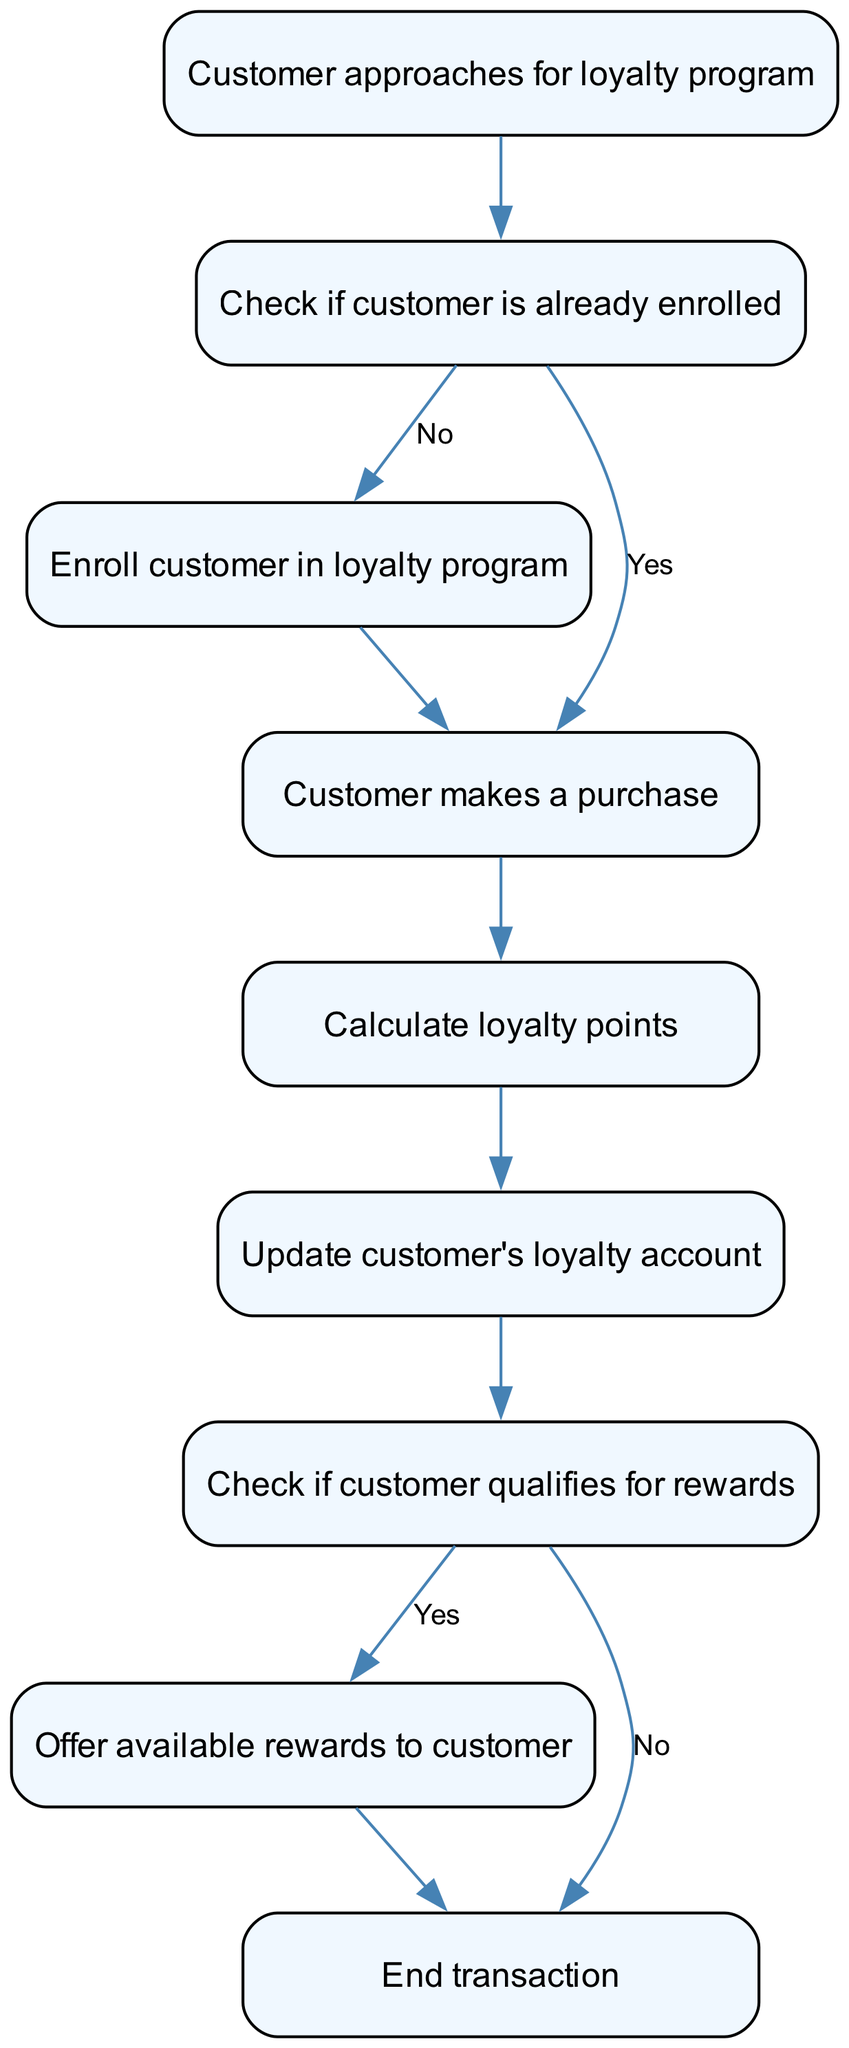What is the first step in the flowchart? The first node in the flowchart is "Customer approaches for loyalty program." This node is labeled "start" and signifies the beginning of the enrollment process for the loyalty program.
Answer: Customer approaches for loyalty program How many nodes are there in the diagram? The diagram contains a total of 9 nodes: "Customer approaches for loyalty program," "Check if customer is already enrolled," "Enroll customer in loyalty program," "Customer makes a purchase," "Calculate loyalty points," "Update customer's loyalty account," "Check if customer qualifies for rewards," "Offer available rewards to customer," and "End transaction."
Answer: 9 What happens if the customer is already enrolled? If the customer is already enrolled, the flow proceeds from the "Check if customer is already enrolled" node directly to the "Customer makes a purchase" node, skipping the enrollment step.
Answer: Customer makes a purchase What is the action taken after the loyalty points are calculated? After loyalty points are calculated, the next step is to "Update customer's loyalty account," which reflects the computed loyalty points in the customer's account.
Answer: Update customer's loyalty account What reward action is taken if the customer qualifies for rewards? If the customer qualifies for rewards, the flow directs to the "Offer available rewards to customer" node, where rewards are presented based on the customer’s eligibility.
Answer: Offer available rewards to customer What is the final step in the flowchart? The final node in the flowchart is "End transaction," indicating the conclusion of the entire process after either offering rewards or confirming the end of transactions.
Answer: End transaction If a customer is not enrolled and makes a purchase, what will happen next? If the customer is not enrolled, they will first go through the "Enroll customer in loyalty program" node before making a purchase. Thus, the flow goes from enrollment to making the purchase.
Answer: Enroll customer in loyalty program What should the workflow follow if the customer does not qualify for rewards? If the customer does not qualify for rewards, the flow chart directs from the "Check if customer qualifies for rewards" node to the "End transaction" node, indicating there are no rewards to be offered.
Answer: End transaction 